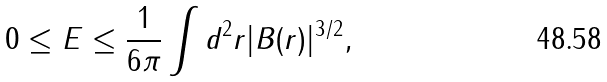Convert formula to latex. <formula><loc_0><loc_0><loc_500><loc_500>0 \leq E \leq \frac { 1 } { 6 \pi } \int d ^ { 2 } r | B ( r ) | ^ { 3 / 2 } ,</formula> 